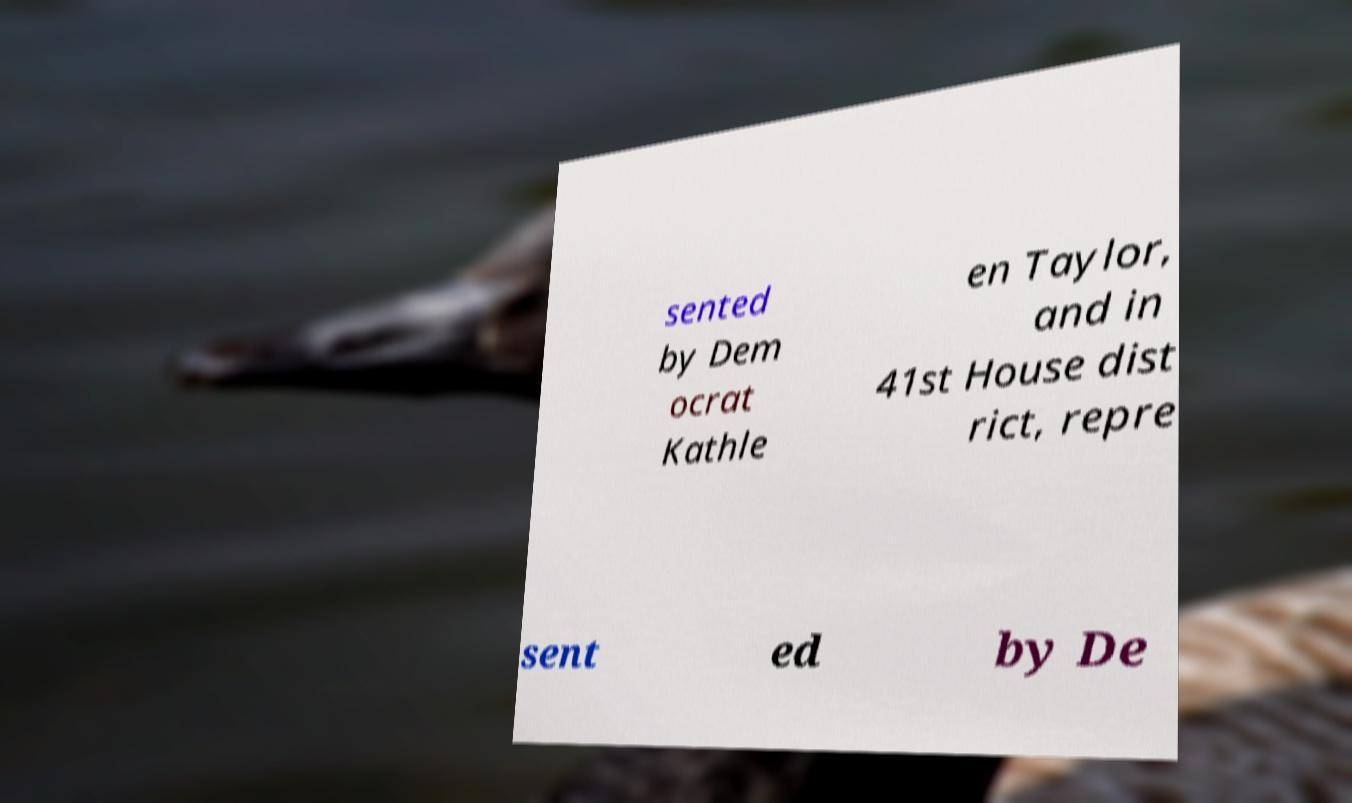Can you read and provide the text displayed in the image?This photo seems to have some interesting text. Can you extract and type it out for me? sented by Dem ocrat Kathle en Taylor, and in 41st House dist rict, repre sent ed by De 